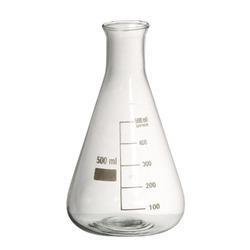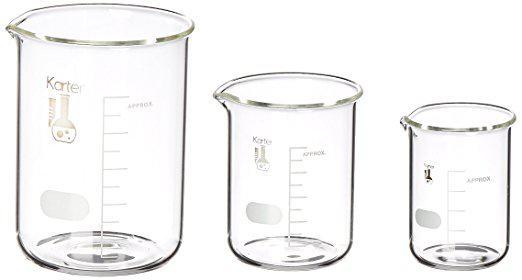The first image is the image on the left, the second image is the image on the right. Analyze the images presented: Is the assertion "Right image contains a single empty glass vessel shaped like a cylinder with a small pour spout on one side." valid? Answer yes or no. No. The first image is the image on the left, the second image is the image on the right. Considering the images on both sides, is "There are two flasks in the pair of images." valid? Answer yes or no. No. 